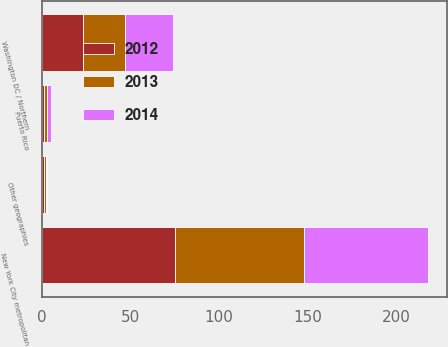Convert chart. <chart><loc_0><loc_0><loc_500><loc_500><stacked_bar_chart><ecel><fcel>New York City metropolitan<fcel>Washington DC / Northern<fcel>Puerto Rico<fcel>Other geographies<nl><fcel>2012<fcel>75<fcel>23<fcel>1<fcel>1<nl><fcel>2013<fcel>73<fcel>24<fcel>2<fcel>1<nl><fcel>2014<fcel>70<fcel>27<fcel>2<fcel>1<nl></chart> 